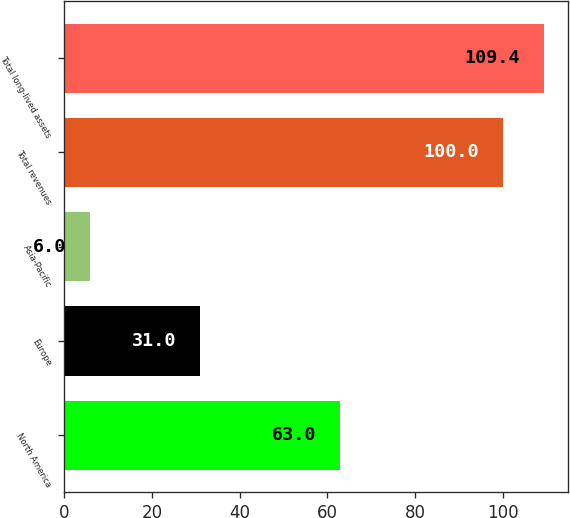<chart> <loc_0><loc_0><loc_500><loc_500><bar_chart><fcel>North America<fcel>Europe<fcel>Asia-Pacific<fcel>Total revenues<fcel>Total long-lived assets<nl><fcel>63<fcel>31<fcel>6<fcel>100<fcel>109.4<nl></chart> 